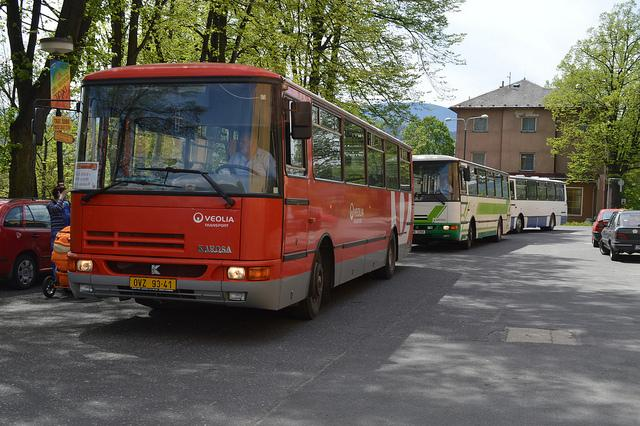Why are the buses lined up? pickup passengers 